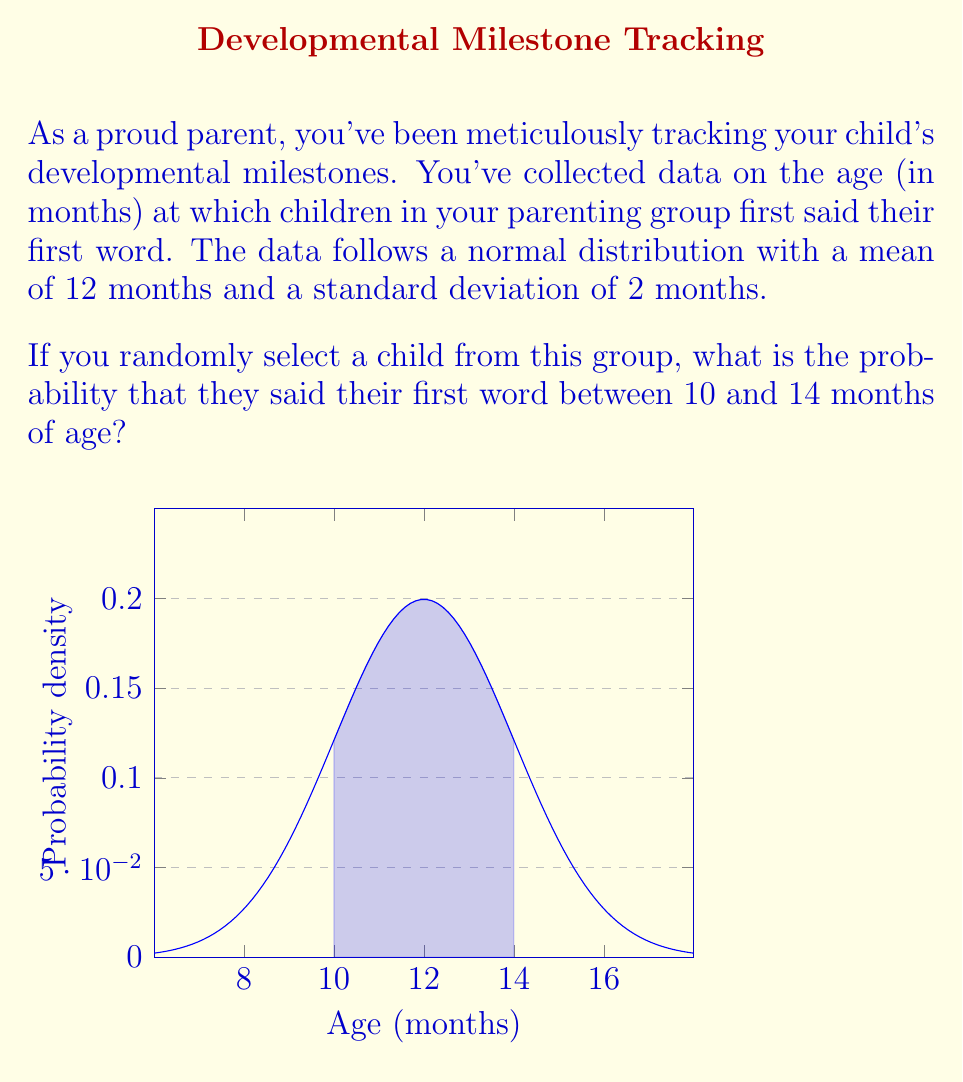What is the answer to this math problem? Let's approach this step-by-step:

1) We're dealing with a normal distribution where:
   $\mu = 12$ months (mean)
   $\sigma = 2$ months (standard deviation)

2) We want to find the probability that a child said their first word between 10 and 14 months.

3) To do this, we need to calculate the z-scores for both 10 and 14 months:

   For 10 months: $z_1 = \frac{10 - 12}{2} = -1$
   For 14 months: $z_2 = \frac{14 - 12}{2} = 1$

4) Now, we need to find the area under the standard normal curve between these z-scores.

5) Using a standard normal table or calculator:
   $P(Z \leq 1) = 0.8413$
   $P(Z \leq -1) = 0.1587$

6) The probability we're looking for is the difference between these:
   $P(-1 \leq Z \leq 1) = 0.8413 - 0.1587 = 0.6826$

7) This means there's a 68.26% chance that a randomly selected child from your group said their first word between 10 and 14 months of age.
Answer: 0.6826 or 68.26% 